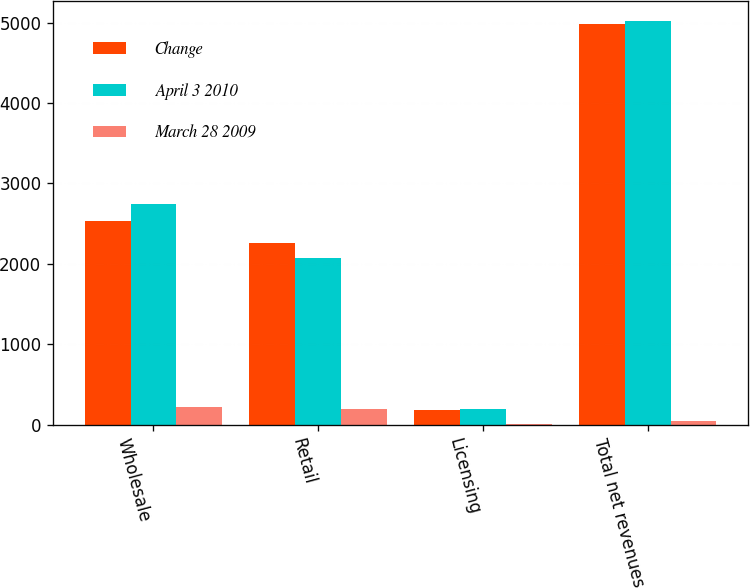<chart> <loc_0><loc_0><loc_500><loc_500><stacked_bar_chart><ecel><fcel>Wholesale<fcel>Retail<fcel>Licensing<fcel>Total net revenues<nl><fcel>Change<fcel>2532.4<fcel>2263.1<fcel>183.4<fcel>4978.9<nl><fcel>April 3 2010<fcel>2749.5<fcel>2074.2<fcel>195.2<fcel>5018.9<nl><fcel>March 28 2009<fcel>217.1<fcel>188.9<fcel>11.8<fcel>40<nl></chart> 